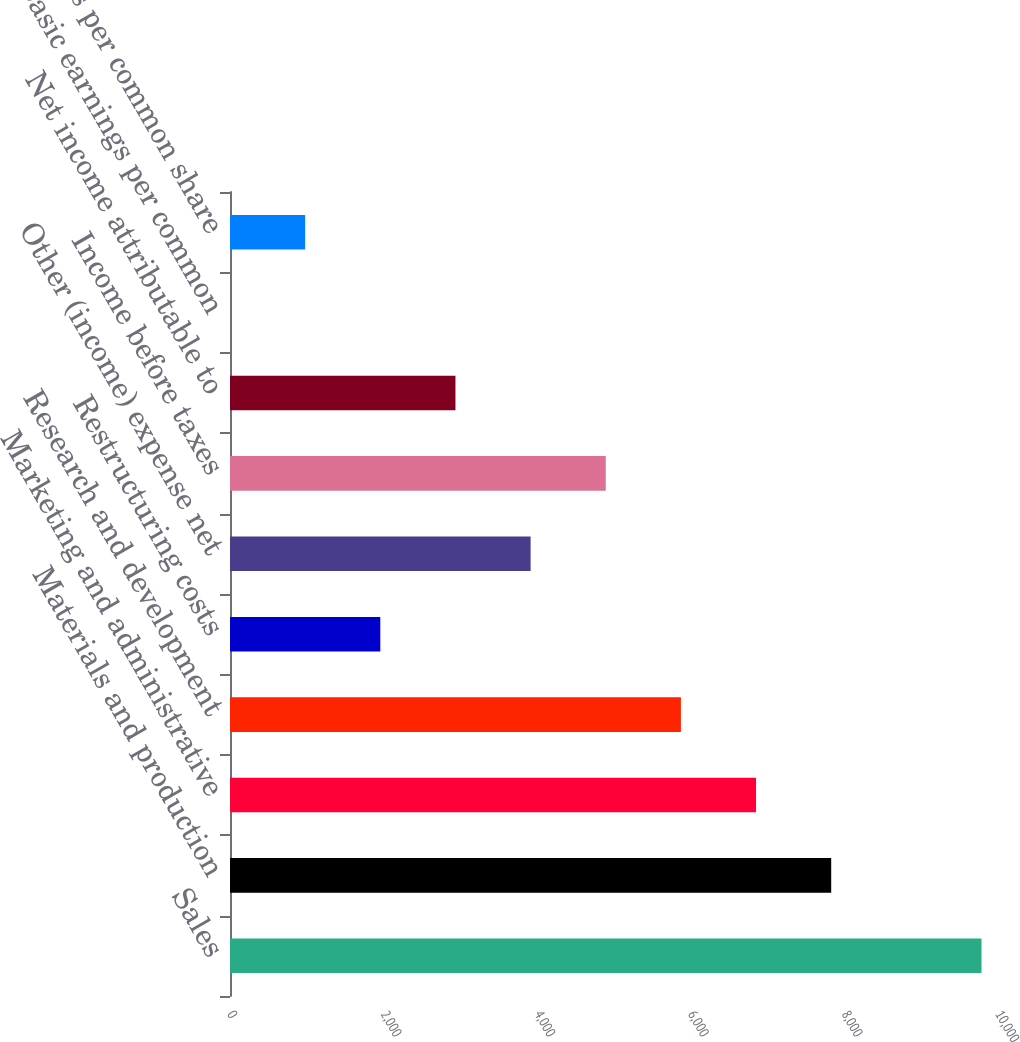Convert chart to OTSL. <chart><loc_0><loc_0><loc_500><loc_500><bar_chart><fcel>Sales<fcel>Materials and production<fcel>Marketing and administrative<fcel>Research and development<fcel>Restructuring costs<fcel>Other (income) expense net<fcel>Income before taxes<fcel>Net income attributable to<fcel>Basic earnings per common<fcel>Earnings per common share<nl><fcel>9785<fcel>7828.08<fcel>6849.6<fcel>5871.12<fcel>1957.2<fcel>3914.16<fcel>4892.64<fcel>2935.68<fcel>0.24<fcel>978.72<nl></chart> 